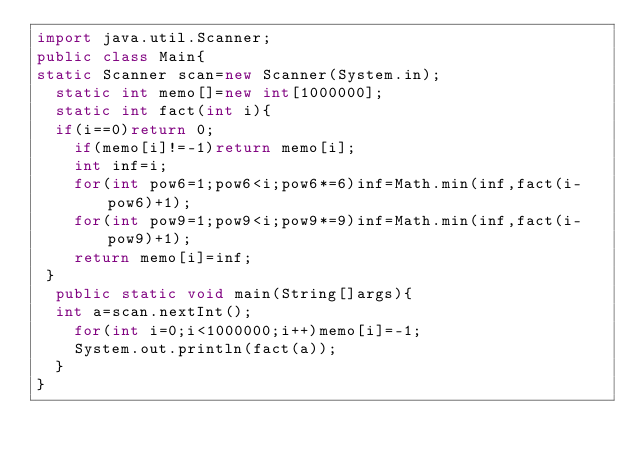<code> <loc_0><loc_0><loc_500><loc_500><_Java_>import java.util.Scanner;
public class Main{
static Scanner scan=new Scanner(System.in);
  static int memo[]=new int[1000000];
  static int fact(int i){
  if(i==0)return 0;
    if(memo[i]!=-1)return memo[i];
    int inf=i;
    for(int pow6=1;pow6<i;pow6*=6)inf=Math.min(inf,fact(i-pow6)+1);
    for(int pow9=1;pow9<i;pow9*=9)inf=Math.min(inf,fact(i-pow9)+1);
    return memo[i]=inf;
 }
  public static void main(String[]args){
  int a=scan.nextInt();
    for(int i=0;i<1000000;i++)memo[i]=-1;
    System.out.println(fact(a));
  }
}
</code> 